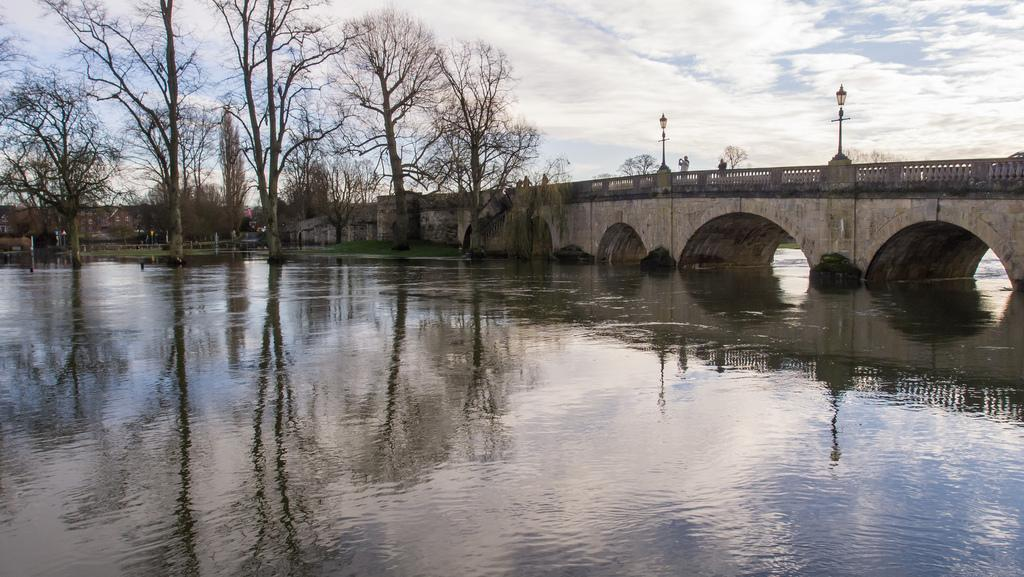What is the main element present in the image? There is water in the image. What structure can be seen on the right side of the image? There is a bridge on the right side of the image. What type of vegetation is present in the image? There are big trees in the image. How does the pear affect the water in the image? There is no pear present in the image, so it cannot affect the water. 